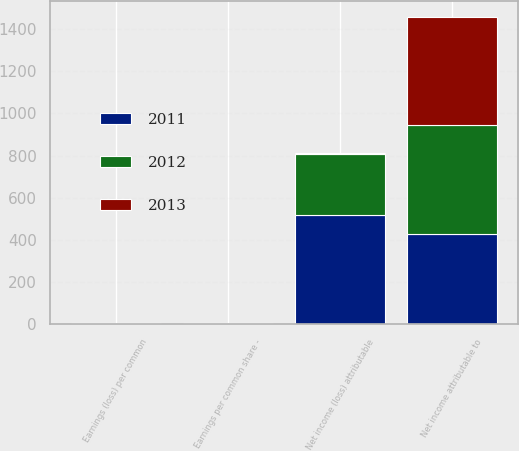Convert chart. <chart><loc_0><loc_0><loc_500><loc_500><stacked_bar_chart><ecel><fcel>Net income (loss) attributable<fcel>Earnings (loss) per common<fcel>Net income attributable to<fcel>Earnings per common share -<nl><fcel>2012<fcel>289<fcel>1.18<fcel>512<fcel>2.1<nl><fcel>2013<fcel>4.01<fcel>4.01<fcel>516<fcel>2.13<nl><fcel>2011<fcel>519<fcel>2.15<fcel>431<fcel>1.79<nl></chart> 